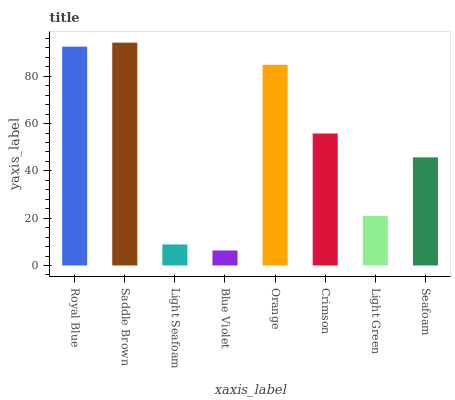Is Light Seafoam the minimum?
Answer yes or no. No. Is Light Seafoam the maximum?
Answer yes or no. No. Is Saddle Brown greater than Light Seafoam?
Answer yes or no. Yes. Is Light Seafoam less than Saddle Brown?
Answer yes or no. Yes. Is Light Seafoam greater than Saddle Brown?
Answer yes or no. No. Is Saddle Brown less than Light Seafoam?
Answer yes or no. No. Is Crimson the high median?
Answer yes or no. Yes. Is Seafoam the low median?
Answer yes or no. Yes. Is Saddle Brown the high median?
Answer yes or no. No. Is Crimson the low median?
Answer yes or no. No. 